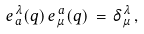Convert formula to latex. <formula><loc_0><loc_0><loc_500><loc_500>e _ { \, a } ^ { \, \lambda } ( q ) \, e ^ { \, a } _ { \, \mu } ( q ) \, = \, \delta ^ { \, \lambda } _ { \, \mu } \, ,</formula> 